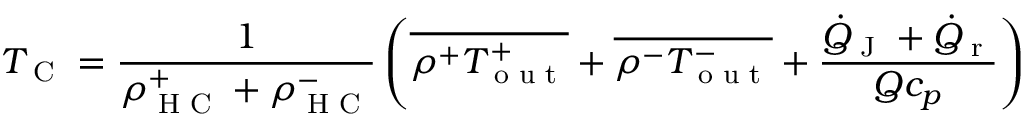Convert formula to latex. <formula><loc_0><loc_0><loc_500><loc_500>T _ { C } = \frac { 1 } { \rho _ { H C } ^ { + } + \rho _ { H C } ^ { - } } \left ( \overline { { \rho ^ { + } T _ { o u t } ^ { + } } } + \overline { { \rho ^ { - } T _ { o u t } ^ { - } } } + \frac { \dot { Q } _ { J } + \dot { Q } _ { r } } { Q c _ { p } } \right )</formula> 